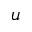Convert formula to latex. <formula><loc_0><loc_0><loc_500><loc_500>u</formula> 